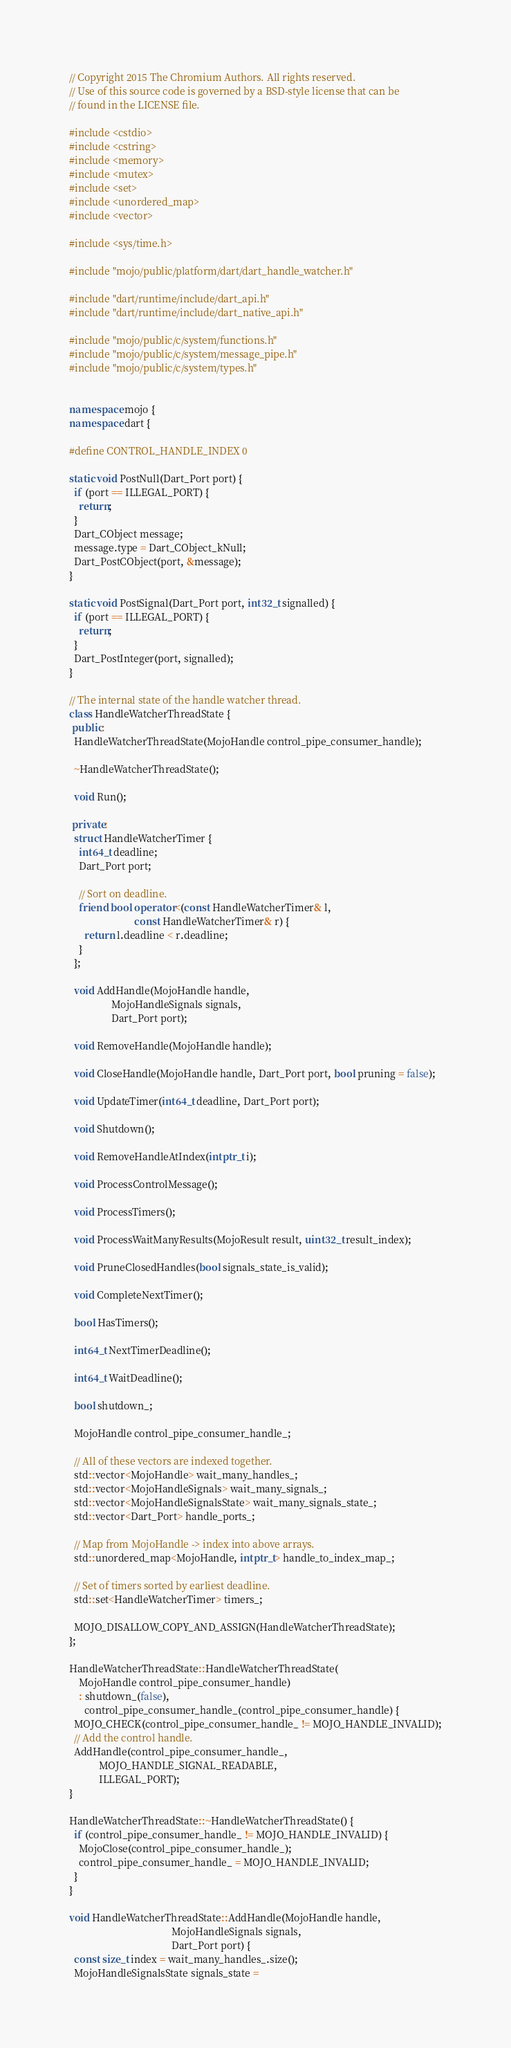Convert code to text. <code><loc_0><loc_0><loc_500><loc_500><_C++_>// Copyright 2015 The Chromium Authors. All rights reserved.
// Use of this source code is governed by a BSD-style license that can be
// found in the LICENSE file.

#include <cstdio>
#include <cstring>
#include <memory>
#include <mutex>
#include <set>
#include <unordered_map>
#include <vector>

#include <sys/time.h>

#include "mojo/public/platform/dart/dart_handle_watcher.h"

#include "dart/runtime/include/dart_api.h"
#include "dart/runtime/include/dart_native_api.h"

#include "mojo/public/c/system/functions.h"
#include "mojo/public/c/system/message_pipe.h"
#include "mojo/public/c/system/types.h"


namespace mojo {
namespace dart {

#define CONTROL_HANDLE_INDEX 0

static void PostNull(Dart_Port port) {
  if (port == ILLEGAL_PORT) {
    return;
  }
  Dart_CObject message;
  message.type = Dart_CObject_kNull;
  Dart_PostCObject(port, &message);
}

static void PostSignal(Dart_Port port, int32_t signalled) {
  if (port == ILLEGAL_PORT) {
    return;
  }
  Dart_PostInteger(port, signalled);
}

// The internal state of the handle watcher thread.
class HandleWatcherThreadState {
 public:
  HandleWatcherThreadState(MojoHandle control_pipe_consumer_handle);

  ~HandleWatcherThreadState();

  void Run();

 private:
  struct HandleWatcherTimer {
    int64_t deadline;
    Dart_Port port;

    // Sort on deadline.
    friend bool operator<(const HandleWatcherTimer& l,
                          const HandleWatcherTimer& r) {
      return l.deadline < r.deadline;
    }
  };

  void AddHandle(MojoHandle handle,
                 MojoHandleSignals signals,
                 Dart_Port port);

  void RemoveHandle(MojoHandle handle);

  void CloseHandle(MojoHandle handle, Dart_Port port, bool pruning = false);

  void UpdateTimer(int64_t deadline, Dart_Port port);

  void Shutdown();

  void RemoveHandleAtIndex(intptr_t i);

  void ProcessControlMessage();

  void ProcessTimers();

  void ProcessWaitManyResults(MojoResult result, uint32_t result_index);

  void PruneClosedHandles(bool signals_state_is_valid);

  void CompleteNextTimer();

  bool HasTimers();

  int64_t NextTimerDeadline();

  int64_t WaitDeadline();

  bool shutdown_;

  MojoHandle control_pipe_consumer_handle_;

  // All of these vectors are indexed together.
  std::vector<MojoHandle> wait_many_handles_;
  std::vector<MojoHandleSignals> wait_many_signals_;
  std::vector<MojoHandleSignalsState> wait_many_signals_state_;
  std::vector<Dart_Port> handle_ports_;

  // Map from MojoHandle -> index into above arrays.
  std::unordered_map<MojoHandle, intptr_t> handle_to_index_map_;

  // Set of timers sorted by earliest deadline.
  std::set<HandleWatcherTimer> timers_;

  MOJO_DISALLOW_COPY_AND_ASSIGN(HandleWatcherThreadState);
};

HandleWatcherThreadState::HandleWatcherThreadState(
    MojoHandle control_pipe_consumer_handle)
    : shutdown_(false),
      control_pipe_consumer_handle_(control_pipe_consumer_handle) {
  MOJO_CHECK(control_pipe_consumer_handle_ != MOJO_HANDLE_INVALID);
  // Add the control handle.
  AddHandle(control_pipe_consumer_handle_,
            MOJO_HANDLE_SIGNAL_READABLE,
            ILLEGAL_PORT);
}

HandleWatcherThreadState::~HandleWatcherThreadState() {
  if (control_pipe_consumer_handle_ != MOJO_HANDLE_INVALID) {
    MojoClose(control_pipe_consumer_handle_);
    control_pipe_consumer_handle_ = MOJO_HANDLE_INVALID;
  }
}

void HandleWatcherThreadState::AddHandle(MojoHandle handle,
                                         MojoHandleSignals signals,
                                         Dart_Port port) {
  const size_t index = wait_many_handles_.size();
  MojoHandleSignalsState signals_state =</code> 